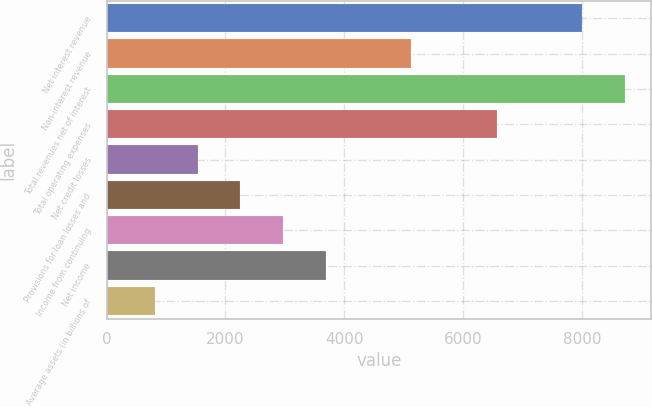Convert chart. <chart><loc_0><loc_0><loc_500><loc_500><bar_chart><fcel>Net interest revenue<fcel>Non-interest revenue<fcel>Total revenues net of interest<fcel>Total operating expenses<fcel>Net credit losses<fcel>Provisions for loan losses and<fcel>Income from continuing<fcel>Net income<fcel>Average assets (in billions of<nl><fcel>8006.4<fcel>5128.8<fcel>8725.8<fcel>6567.6<fcel>1531.8<fcel>2251.2<fcel>2970.6<fcel>3690<fcel>812.4<nl></chart> 